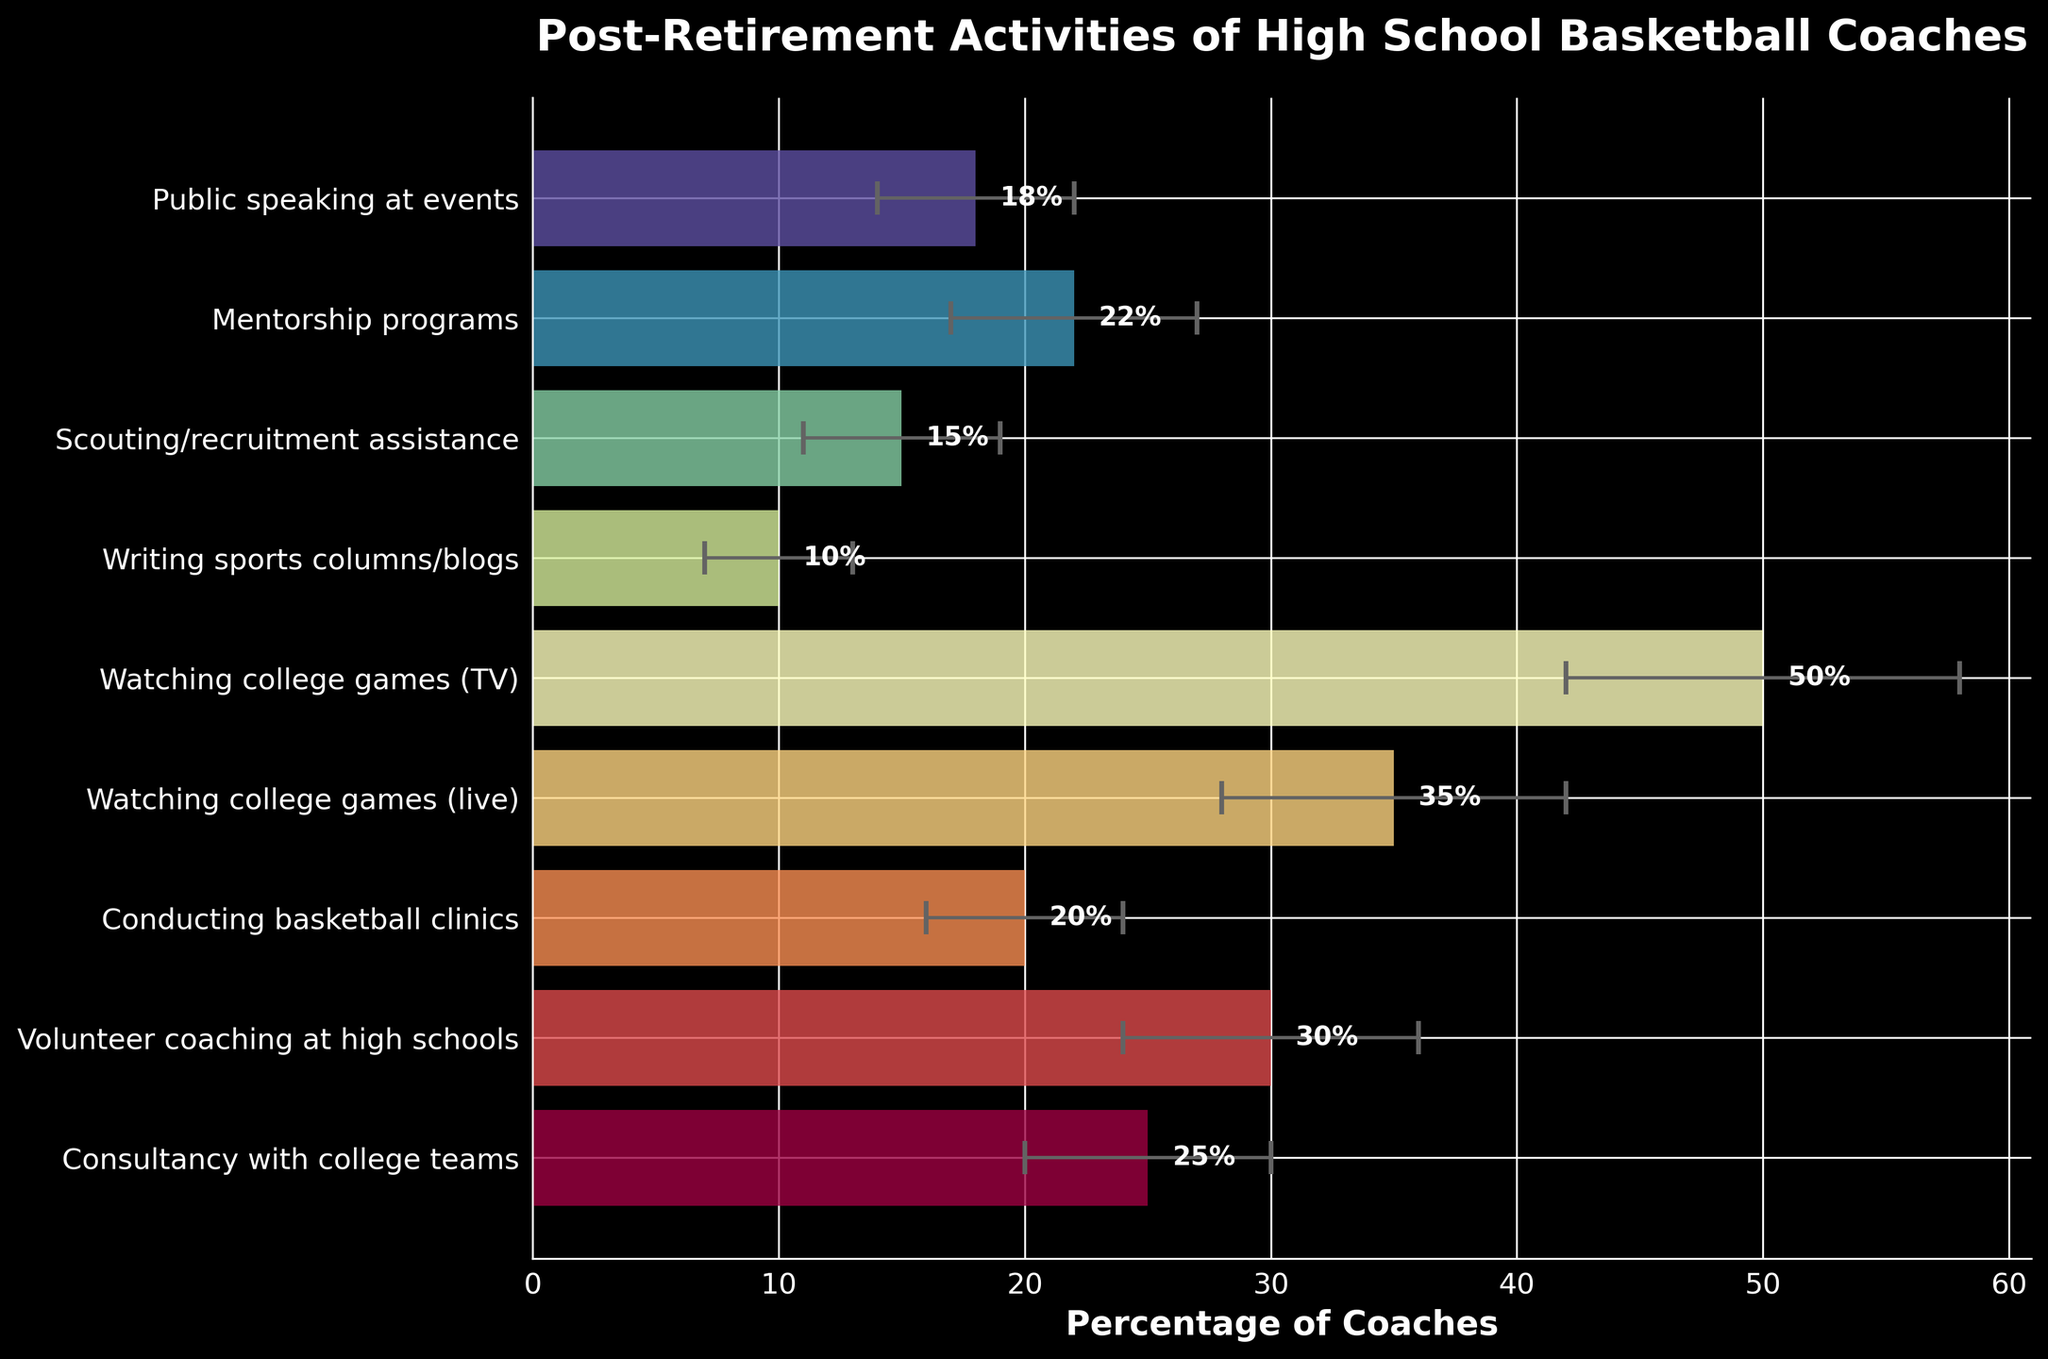Which activity has the highest average percentage of engagement? By looking at the bar lengths, the activity "Watching college games (TV)" has the longest bar, indicating the highest average percentage. This is also confirmed by reading the specific percentage value of 50%.
Answer: Watching college games (TV) What is the difference in average percentage between watching college games on TV and writing sports columns/blogs? The average percentage for watching college games on TV is 50%, and for writing sports columns/blogs, it's 10%. The difference is 50% - 10% = 40%.
Answer: 40% Which activities have an error bar length of 6%? By examining the length of the error bars in the figure, "Volunteer coaching at high schools" is associated with an error bar of 6%.
Answer: Volunteer coaching at high schools Are there any activities with the same standard deviation? Yes, "Consultancy with college teams" and "Mentorship programs" both have a standard deviation of 5%.
Answer: Consultancy with college teams, Mentorship programs Which activity has the lowest average percentage of engagement? By observing the shortest bars in the figure, "Writing sports columns/blogs" has the shortest bar, indicating the lowest average percentage of 10%.
Answer: Writing sports columns/blogs How many activities have a mean percentage above 20%? The activities with mean percentages above 20% are "Consultancy with college teams" (25%), "Volunteer coaching at high schools" (30%), "Watching college games (live)" (35%), and "Watching college games (TV)" (50%). Counting them, there are 4 activities.
Answer: 4 What are the error bars' lengths for the activity "Watching college games (live)"? The error bars' length for "Watching college games (live)" is 7%, as indicated next to the corresponding bar.
Answer: 7% Which activity has the same average percentage as the activity with the lowest standard deviation? "Watching college games (TV)" has an average of 50%, but the activity with the lowest standard deviation is "Writing sports columns/blogs" (3%). Since they don't match, there is no activity that fits this description.
Answer: None 